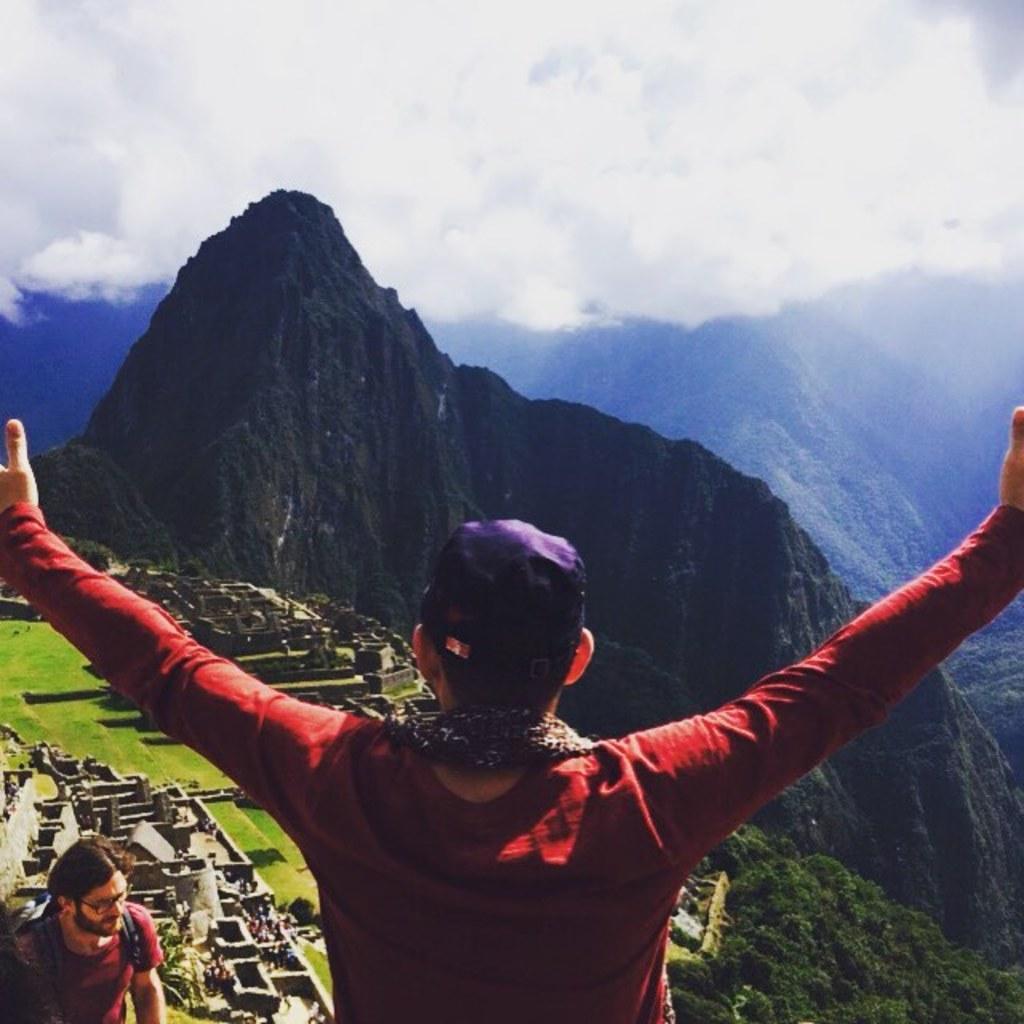Please provide a concise description of this image. In the picture it looks like some hill station, there are two people and around them there is some architecture and in the background there are mountains and on the right side there are a lot of trees. 